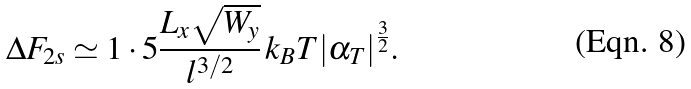Convert formula to latex. <formula><loc_0><loc_0><loc_500><loc_500>\Delta F _ { 2 s } \simeq 1 \cdot 5 \frac { L _ { x } \sqrt { W _ { y } } } { l ^ { 3 / 2 } } \, k _ { B } T { | \alpha _ { T } | } ^ { \frac { 3 } { 2 } } .</formula> 